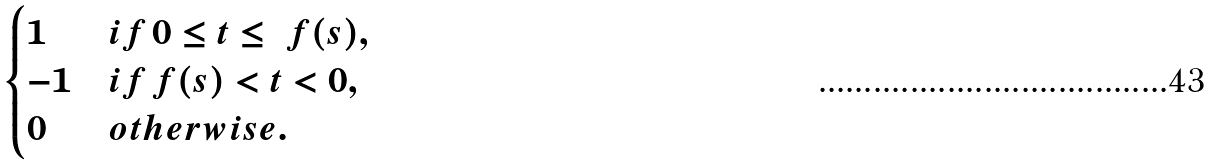<formula> <loc_0><loc_0><loc_500><loc_500>\begin{cases} 1 & i f \, 0 \leq t \leq \ f ( s ) , \\ - 1 & i f \, f ( s ) < t < 0 , \\ 0 & o t h e r w i s e . \end{cases}</formula> 